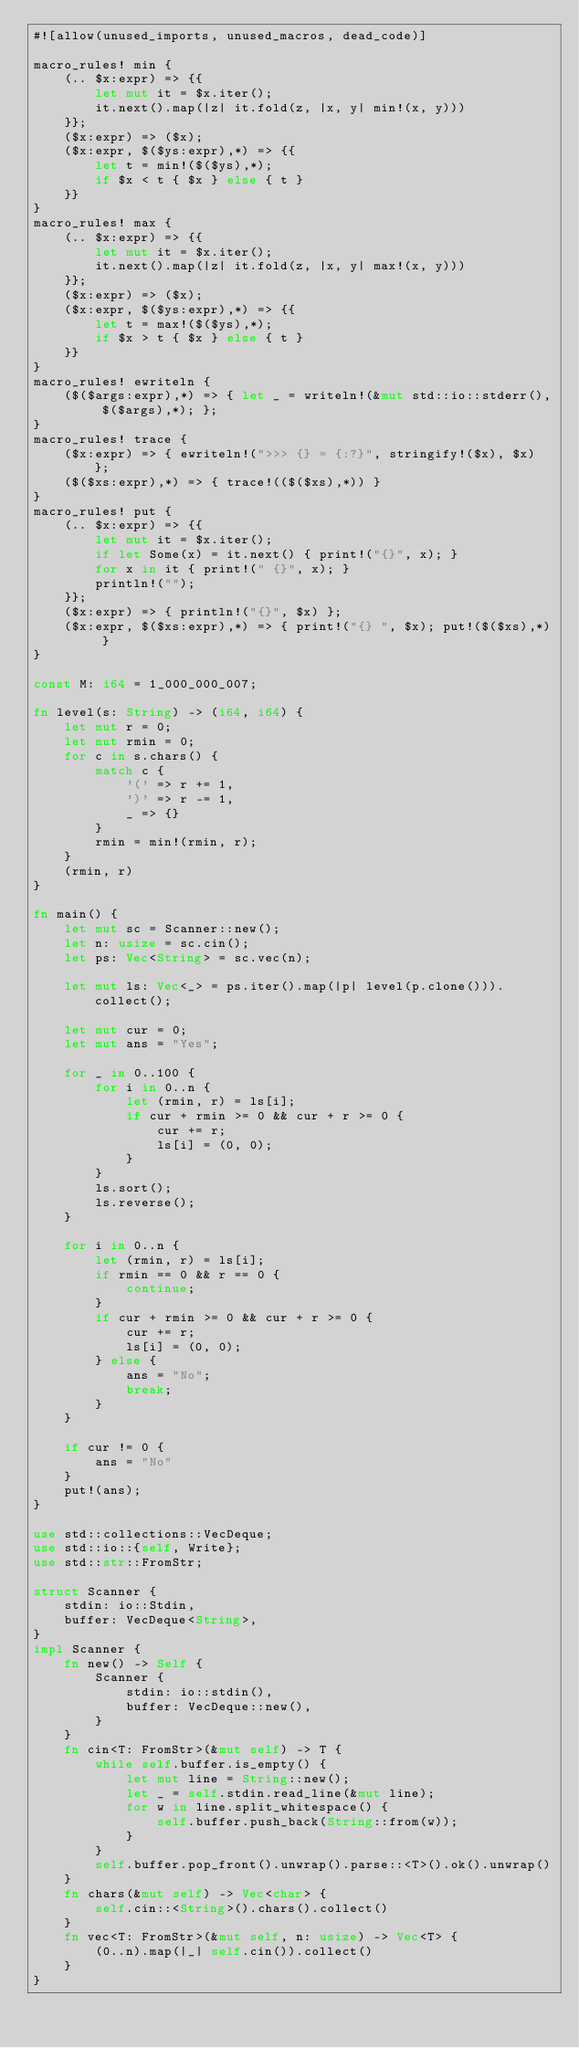<code> <loc_0><loc_0><loc_500><loc_500><_Rust_>#![allow(unused_imports, unused_macros, dead_code)]

macro_rules! min {
    (.. $x:expr) => {{
        let mut it = $x.iter();
        it.next().map(|z| it.fold(z, |x, y| min!(x, y)))
    }};
    ($x:expr) => ($x);
    ($x:expr, $($ys:expr),*) => {{
        let t = min!($($ys),*);
        if $x < t { $x } else { t }
    }}
}
macro_rules! max {
    (.. $x:expr) => {{
        let mut it = $x.iter();
        it.next().map(|z| it.fold(z, |x, y| max!(x, y)))
    }};
    ($x:expr) => ($x);
    ($x:expr, $($ys:expr),*) => {{
        let t = max!($($ys),*);
        if $x > t { $x } else { t }
    }}
}
macro_rules! ewriteln {
    ($($args:expr),*) => { let _ = writeln!(&mut std::io::stderr(), $($args),*); };
}
macro_rules! trace {
    ($x:expr) => { ewriteln!(">>> {} = {:?}", stringify!($x), $x) };
    ($($xs:expr),*) => { trace!(($($xs),*)) }
}
macro_rules! put {
    (.. $x:expr) => {{
        let mut it = $x.iter();
        if let Some(x) = it.next() { print!("{}", x); }
        for x in it { print!(" {}", x); }
        println!("");
    }};
    ($x:expr) => { println!("{}", $x) };
    ($x:expr, $($xs:expr),*) => { print!("{} ", $x); put!($($xs),*) }
}

const M: i64 = 1_000_000_007;

fn level(s: String) -> (i64, i64) {
    let mut r = 0;
    let mut rmin = 0;
    for c in s.chars() {
        match c {
            '(' => r += 1,
            ')' => r -= 1,
            _ => {}
        }
        rmin = min!(rmin, r);
    }
    (rmin, r)
}

fn main() {
    let mut sc = Scanner::new();
    let n: usize = sc.cin();
    let ps: Vec<String> = sc.vec(n);

    let mut ls: Vec<_> = ps.iter().map(|p| level(p.clone())).collect();

    let mut cur = 0;
    let mut ans = "Yes";

    for _ in 0..100 {
        for i in 0..n {
            let (rmin, r) = ls[i];
            if cur + rmin >= 0 && cur + r >= 0 {
                cur += r;
                ls[i] = (0, 0);
            }
        }
        ls.sort();
        ls.reverse();
    }

    for i in 0..n {
        let (rmin, r) = ls[i];
        if rmin == 0 && r == 0 {
            continue;
        }
        if cur + rmin >= 0 && cur + r >= 0 {
            cur += r;
            ls[i] = (0, 0);
        } else {
            ans = "No";
            break;
        }
    }

    if cur != 0 {
        ans = "No"
    }
    put!(ans);
}

use std::collections::VecDeque;
use std::io::{self, Write};
use std::str::FromStr;

struct Scanner {
    stdin: io::Stdin,
    buffer: VecDeque<String>,
}
impl Scanner {
    fn new() -> Self {
        Scanner {
            stdin: io::stdin(),
            buffer: VecDeque::new(),
        }
    }
    fn cin<T: FromStr>(&mut self) -> T {
        while self.buffer.is_empty() {
            let mut line = String::new();
            let _ = self.stdin.read_line(&mut line);
            for w in line.split_whitespace() {
                self.buffer.push_back(String::from(w));
            }
        }
        self.buffer.pop_front().unwrap().parse::<T>().ok().unwrap()
    }
    fn chars(&mut self) -> Vec<char> {
        self.cin::<String>().chars().collect()
    }
    fn vec<T: FromStr>(&mut self, n: usize) -> Vec<T> {
        (0..n).map(|_| self.cin()).collect()
    }
}
</code> 